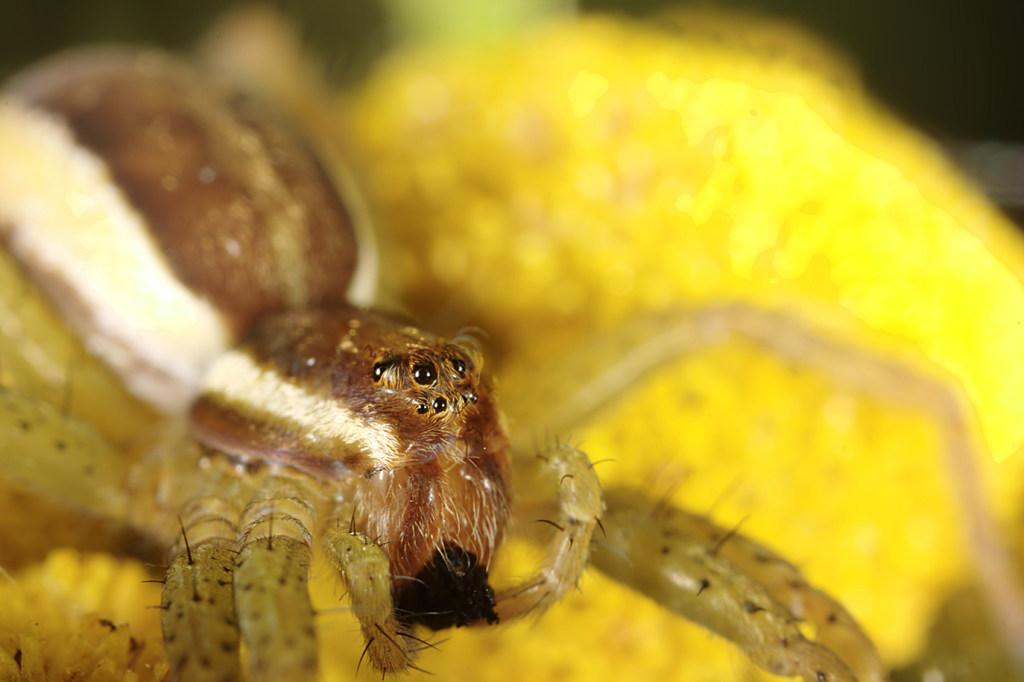What is the main subject of the image? The main subject of the image is an insect. How close is the view of the insect in the image? The image has a zoomed-in view of the insect. What can be observed about the background of the image? The background of the insect is blurred. What type of powder can be seen falling on the insect in the image? There is no powder present in the image; it only features the insect with a blurred background. 